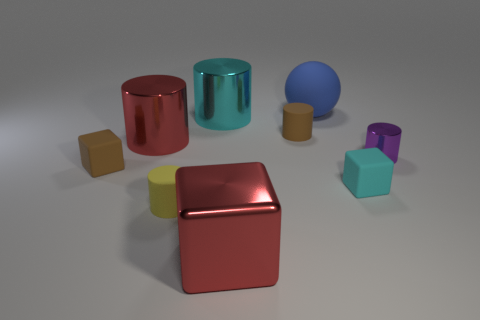There is a red shiny thing that is the same shape as the cyan metal object; what is its size?
Your answer should be compact. Large. Are there any yellow cylinders?
Your response must be concise. Yes. What number of objects are cylinders in front of the brown cylinder or tiny cyan objects?
Offer a terse response. 4. What is the material of the blue thing that is the same size as the cyan cylinder?
Your answer should be very brief. Rubber. What color is the rubber block that is to the left of the matte cylinder left of the small brown cylinder?
Your answer should be very brief. Brown. There is a big ball; how many big cyan cylinders are left of it?
Make the answer very short. 1. The large sphere has what color?
Make the answer very short. Blue. How many small things are either gray rubber cylinders or brown rubber cubes?
Ensure brevity in your answer.  1. Do the tiny rubber cylinder that is behind the small cyan matte cube and the matte block that is to the left of the tiny brown matte cylinder have the same color?
Provide a succinct answer. Yes. How many other things are the same color as the metallic block?
Offer a terse response. 1. 